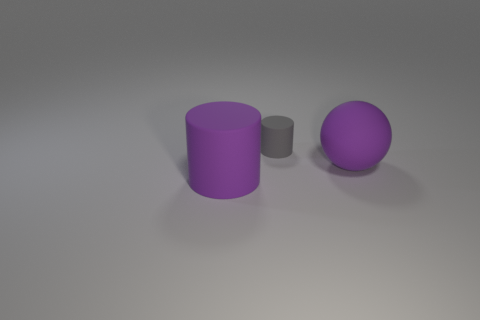Add 3 large gray matte cylinders. How many objects exist? 6 Subtract all spheres. How many objects are left? 2 Subtract 0 brown cylinders. How many objects are left? 3 Subtract all tiny gray cylinders. Subtract all large rubber cylinders. How many objects are left? 1 Add 2 big purple matte cylinders. How many big purple matte cylinders are left? 3 Add 1 big cylinders. How many big cylinders exist? 2 